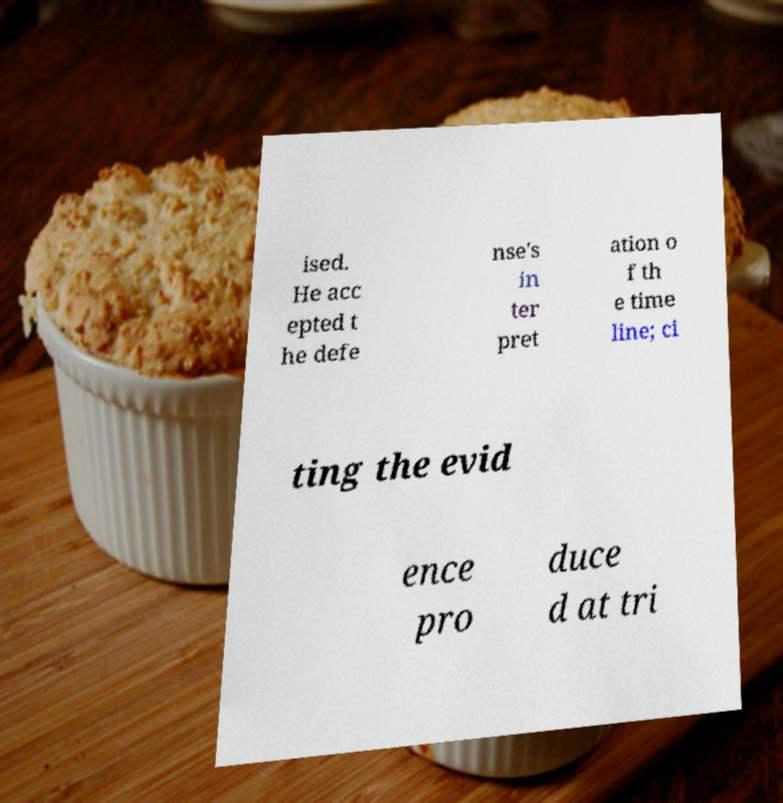Please read and relay the text visible in this image. What does it say? ised. He acc epted t he defe nse's in ter pret ation o f th e time line; ci ting the evid ence pro duce d at tri 